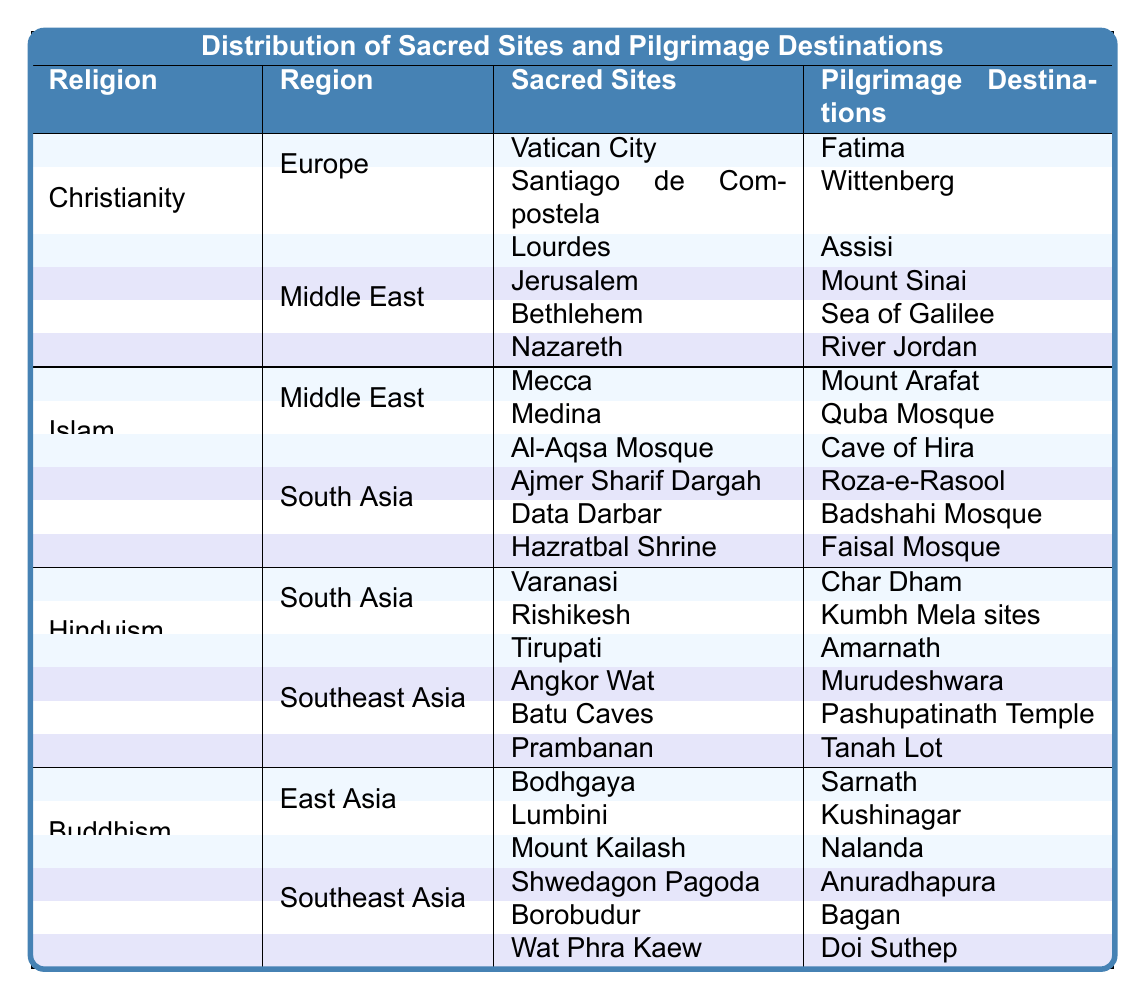What are the sacred sites associated with Hinduism in South Asia? The table lists the sacred sites for Hinduism in South Asia, which are Varanasi, Rishikesh, and Tirupati.
Answer: Varanasi, Rishikesh, Tirupati How many pilgrimage destinations are there for Buddhism in Southeast Asia? According to the table, there are three pilgrimage destinations listed under Buddhism in Southeast Asia: Anuradhapura, Bagan, and Doi Suthep.
Answer: Three Is the Al-Aqsa Mosque a sacred site of Islam? The table indicates that Al-Aqsa Mosque is indeed listed as a sacred site under the religion of Islam in the Middle East region.
Answer: Yes Which religion has the most sacred sites located in Europe? The data shows that Christianity has three sacred sites in Europe (Vatican City, Santiago de Compostela, and Lourdes), while no other religion has any sites listed in that region. Therefore, Christianity has the most.
Answer: Christianity Are all pilgrimage destinations for Islam located in the Middle East? The table lists pilgrimage destinations for Islam in two regions: the Middle East and South Asia, including destinations like Roza-e-Rasool and Badshahi Mosque that are not in the Middle East. Hence, not all are located there.
Answer: No What is the total number of sacred sites listed for Buddhism across both regions? The table presents three sacred sites in East Asia (Bodhgaya, Lumbini, Mount Kailash) and three in Southeast Asia (Shwedagon Pagoda, Borobudur, Wat Phra Kaew). Therefore, adding these gives a total of six sacred sites.
Answer: Six Which religion's sacred site is located in Vatican City? The table shows that the sacred site located in Vatican City belongs to Christianity.
Answer: Christianity Which religion has the fewest pilgrimage destinations listed? Reviewing the table, Hinduism and Buddhism both have three pilgrimage destinations listed each, while Christianity and Islam have more. Therefore, Hinduism and Buddhism are tied for the fewest.
Answer: Hinduism and Buddhism What are the themes of pilgrimage destinations in South Asia? The table reveals that the pilgrimage destinations in South Asia under Islam are Roza-e-Rasool, Badshahi Mosque, and Faisal Mosque, which emphasize Islamic heritage and religious significance in the region.
Answer: Islamic heritage Is Lourdes a pilgrimage destination? Referring to the table, Lourdes is listed as a sacred site under Christianity, not specifically as a pilgrimage destination, which is different. Hence, Lourdes itself is not categorized as a pilgrimage destination.
Answer: No 